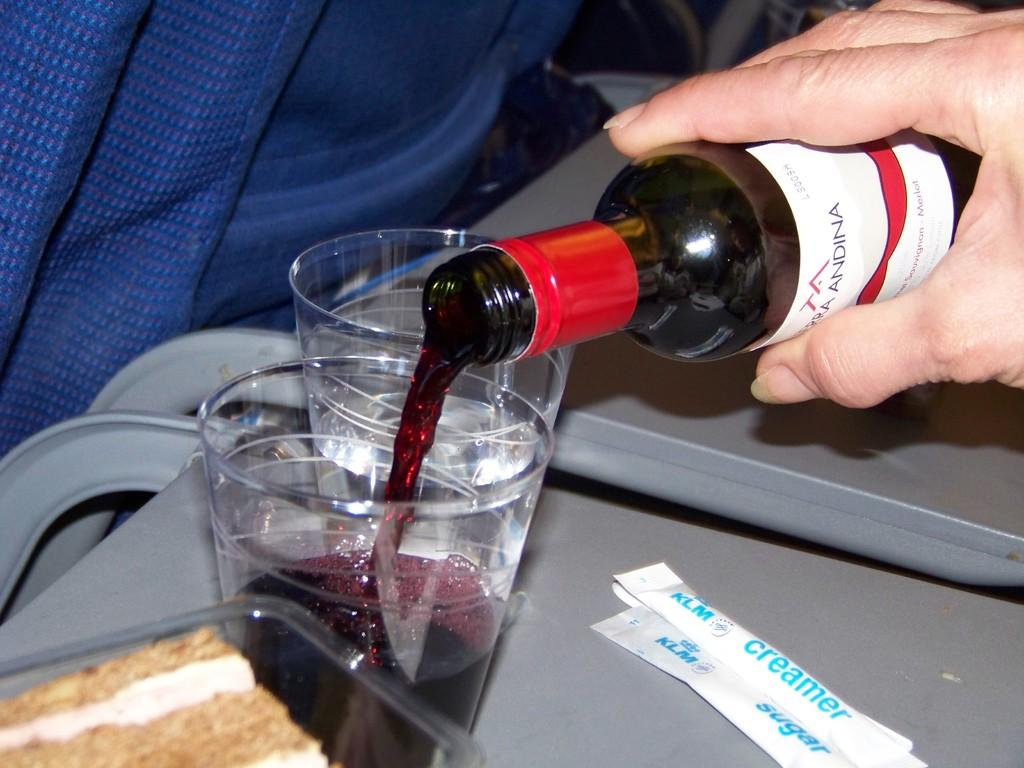Provide a one-sentence caption for the provided image. hand pouring liquid from a bottle into a cup and pakcets of klm creamer and klm sugar next to cup. 